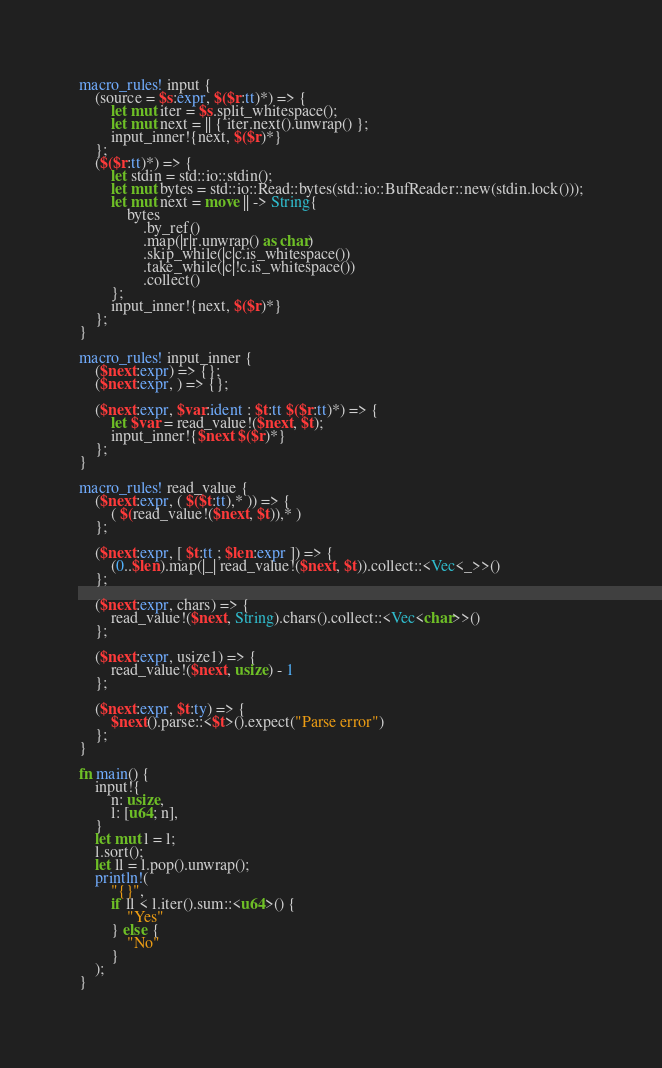<code> <loc_0><loc_0><loc_500><loc_500><_Rust_>macro_rules! input {
    (source = $s:expr, $($r:tt)*) => {
        let mut iter = $s.split_whitespace();
        let mut next = || { iter.next().unwrap() };
        input_inner!{next, $($r)*}
    };
    ($($r:tt)*) => {
        let stdin = std::io::stdin();
        let mut bytes = std::io::Read::bytes(std::io::BufReader::new(stdin.lock()));
        let mut next = move || -> String{
            bytes
                .by_ref()
                .map(|r|r.unwrap() as char)
                .skip_while(|c|c.is_whitespace())
                .take_while(|c|!c.is_whitespace())
                .collect()
        };
        input_inner!{next, $($r)*}
    };
}

macro_rules! input_inner {
    ($next:expr) => {};
    ($next:expr, ) => {};

    ($next:expr, $var:ident : $t:tt $($r:tt)*) => {
        let $var = read_value!($next, $t);
        input_inner!{$next $($r)*}
    };
}

macro_rules! read_value {
    ($next:expr, ( $($t:tt),* )) => {
        ( $(read_value!($next, $t)),* )
    };

    ($next:expr, [ $t:tt ; $len:expr ]) => {
        (0..$len).map(|_| read_value!($next, $t)).collect::<Vec<_>>()
    };

    ($next:expr, chars) => {
        read_value!($next, String).chars().collect::<Vec<char>>()
    };

    ($next:expr, usize1) => {
        read_value!($next, usize) - 1
    };

    ($next:expr, $t:ty) => {
        $next().parse::<$t>().expect("Parse error")
    };
}

fn main() {
    input!{
        n: usize,
        l: [u64; n],
    }
    let mut l = l;
    l.sort();
    let ll = l.pop().unwrap();
    println!(
        "{}",
        if ll < l.iter().sum::<u64>() {
            "Yes"
        } else {
            "No"
        }
    );
}
</code> 